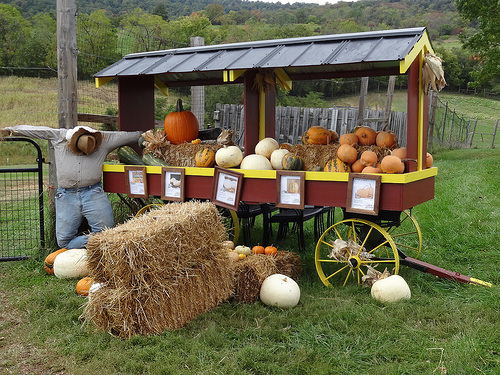<image>
Is there a pumkin on the hay? No. The pumkin is not positioned on the hay. They may be near each other, but the pumkin is not supported by or resting on top of the hay. 